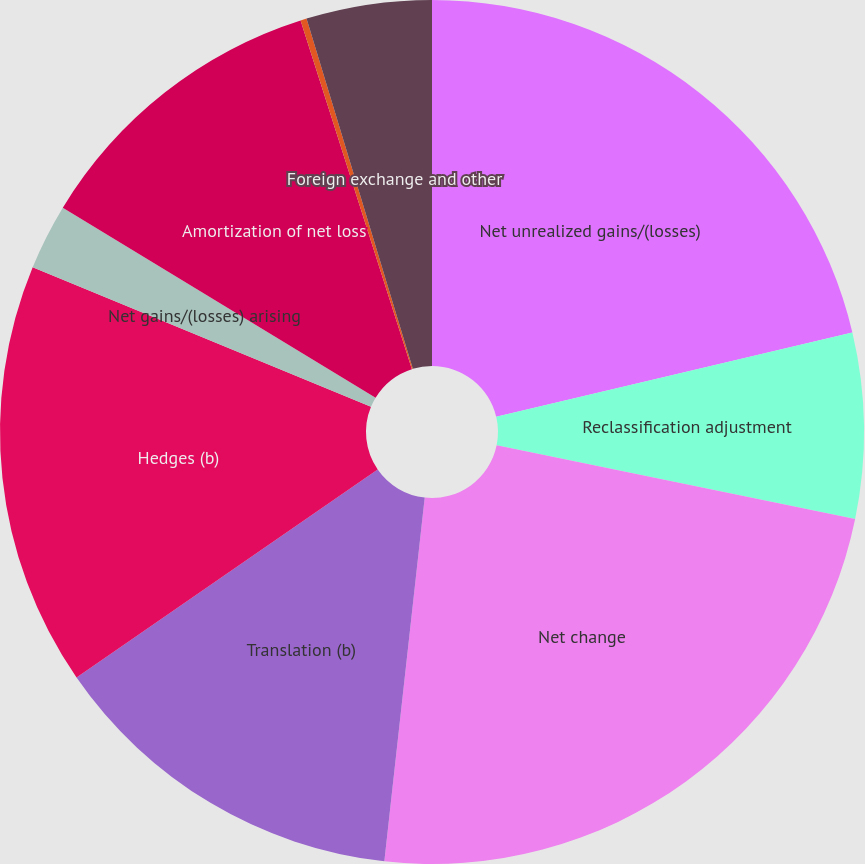Convert chart. <chart><loc_0><loc_0><loc_500><loc_500><pie_chart><fcel>Net unrealized gains/(losses)<fcel>Reclassification adjustment<fcel>Net change<fcel>Translation (b)<fcel>Hedges (b)<fcel>Net gains/(losses) arising<fcel>Amortization of net loss<fcel>Prior service costs/(credits)<fcel>Foreign exchange and other<nl><fcel>21.3%<fcel>6.93%<fcel>23.53%<fcel>13.62%<fcel>15.85%<fcel>2.46%<fcel>11.39%<fcel>0.23%<fcel>4.69%<nl></chart> 